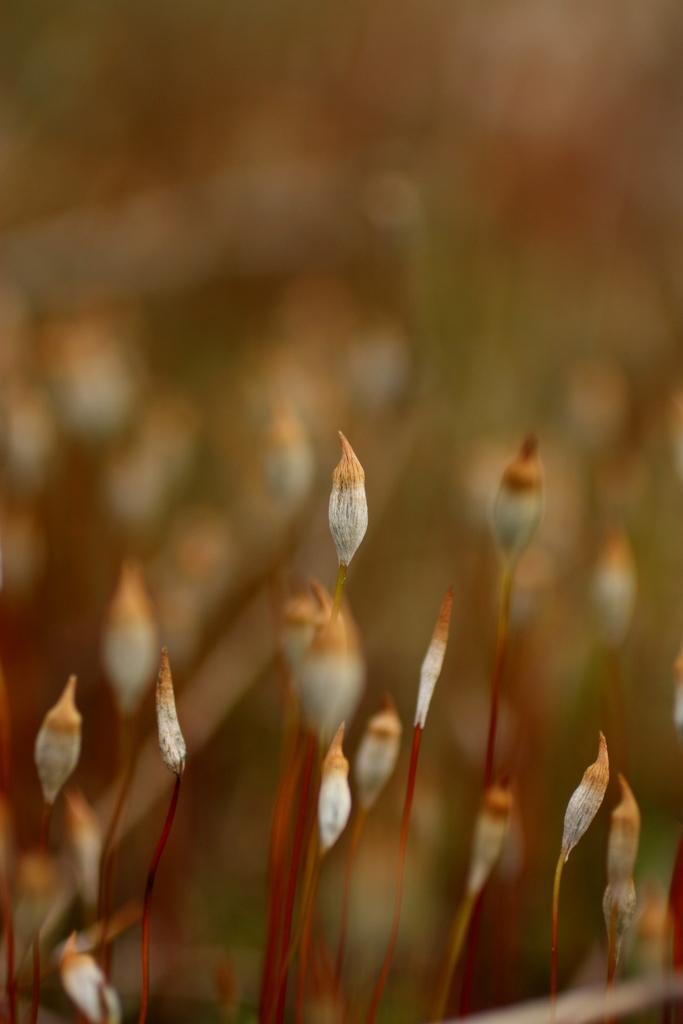In one or two sentences, can you explain what this image depicts? In the image it is a zoomin picture of a plant. 